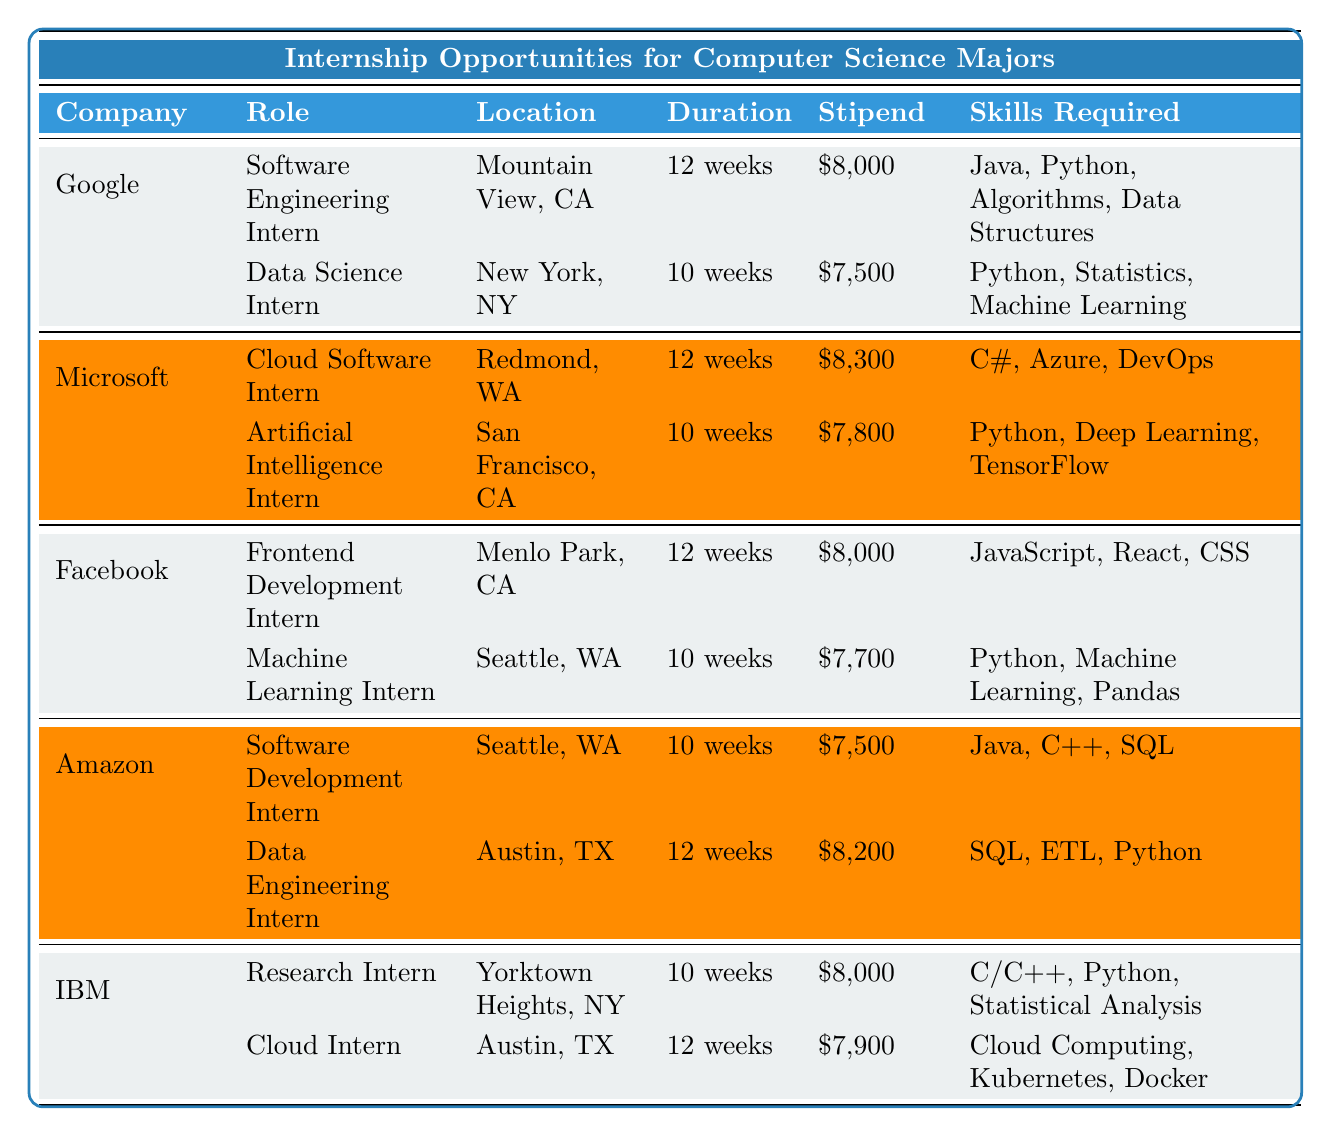What is the stipend for the Software Engineering Intern at Google? The table lists the stipend for the Software Engineering Intern role at Google as $8,000.
Answer: $8,000 How long is the internship for the Data Science Intern at Google? The table indicates that the duration of the internship for the Data Science Intern at Google is 10 weeks.
Answer: 10 weeks Which company offers a Cloud Software Intern position? Referring to the table, Microsoft is the company that offers a Cloud Software Intern position.
Answer: Microsoft Are there any internships with a stipend over $8,000? By reviewing the stipends listed, Microsoft’s Cloud Software Intern has a stipend of $8,300 which is over $8,000, and the Cloud Intern at IBM has a stipend of $7,900, which is not over $8,000. Hence, yes, at least one internship exceeds $8,000.
Answer: Yes What is the difference in stipend between the Frontend Development Intern at Facebook and the Software Development Intern at Amazon? The stipend for the Frontend Development Intern at Facebook is $8,000, and for the Software Development Intern at Amazon, it is $7,500. The difference is $8,000 - $7,500 = $500.
Answer: $500 Which internship has the longest duration, and what is that duration? Scanning through the table, both the Software Engineering Intern at Google and the Cloud Software Intern at Microsoft have the longest duration of 12 weeks.
Answer: 12 weeks Can you find an internship that requires knowledge of Python and is located in New York? According to the table, the Data Science Intern at Google, which is located in New York, requires skills in Python. Hence, yes, such an internship exists.
Answer: Yes What are the skills required for the Machine Learning Intern at Facebook? The table shows that the skills required for the Machine Learning Intern at Facebook include Python, Machine Learning, and Pandas.
Answer: Python, Machine Learning, Pandas Which company offers the highest stipend for the longest internship duration? To find this, we see that Microsoft offers the highest stipend of $8,300 for the Cloud Software Intern with a duration of 12 weeks, which is the longest duration among the listed internships.
Answer: Microsoft How many internships have a two-digit stipend amount? Observing the stipend values, there are four internships with two-digit stipend amounts: Google’s Data Science Intern ($7,500), Facebook’s Machine Learning Intern ($7,700), Amazon’s Software Development Intern ($7,500), and IBM's Cloud Intern ($7,900). Thus, a total of four internships fit this criterion.
Answer: 4 